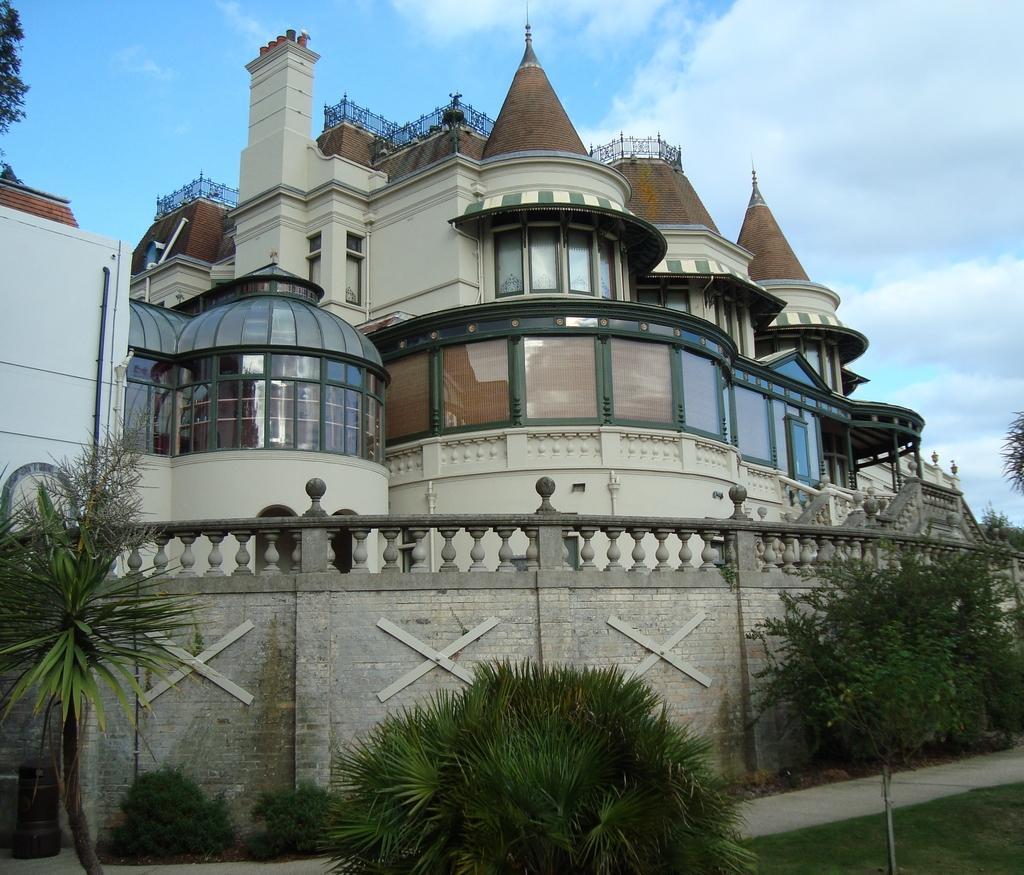Describe this image in one or two sentences. This picture shows buildings and we see trees and a compound wall and we see a blue cloudy sky. 